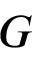<formula> <loc_0><loc_0><loc_500><loc_500>G \/</formula> 